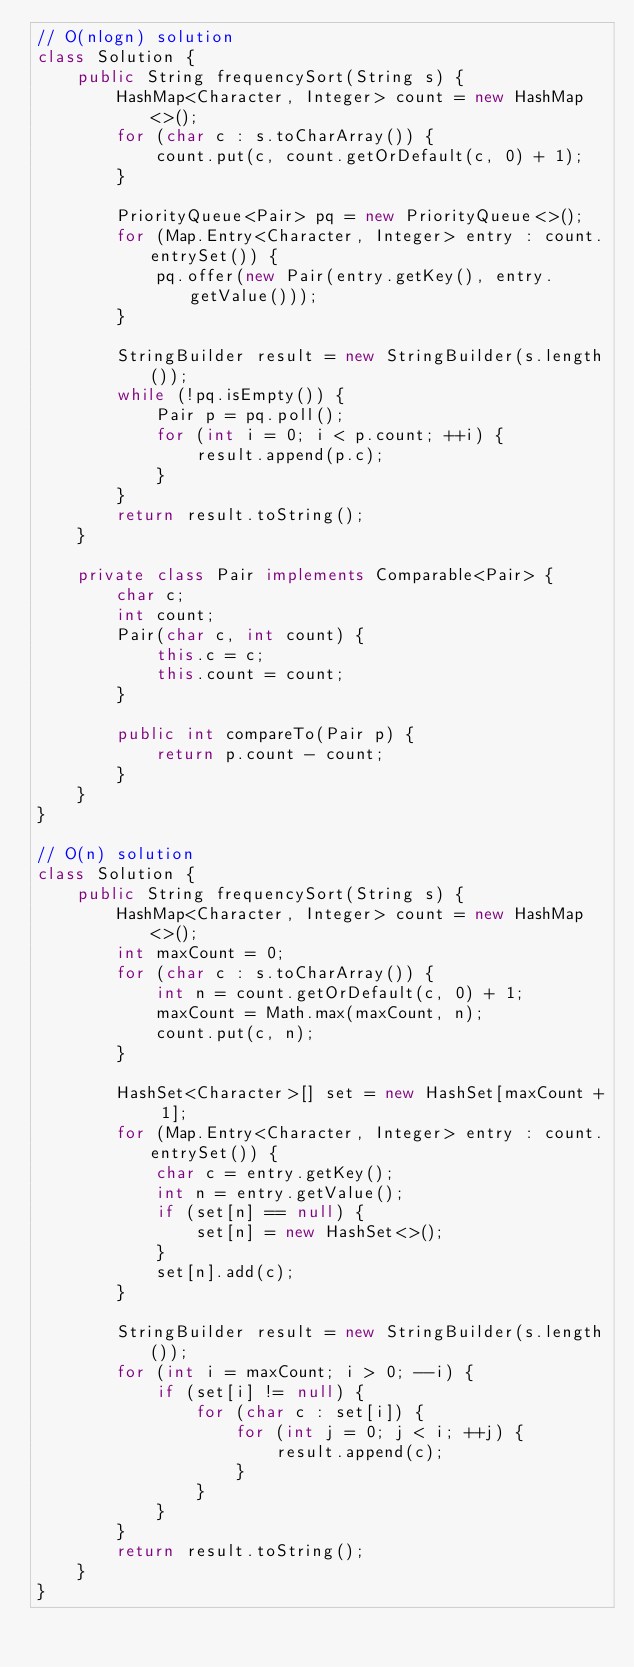<code> <loc_0><loc_0><loc_500><loc_500><_Java_>// O(nlogn) solution
class Solution {
    public String frequencySort(String s) {
        HashMap<Character, Integer> count = new HashMap<>();
        for (char c : s.toCharArray()) {
            count.put(c, count.getOrDefault(c, 0) + 1);
        }
        
        PriorityQueue<Pair> pq = new PriorityQueue<>();
        for (Map.Entry<Character, Integer> entry : count.entrySet()) {
            pq.offer(new Pair(entry.getKey(), entry.getValue()));
        }
        
        StringBuilder result = new StringBuilder(s.length());
        while (!pq.isEmpty()) {
            Pair p = pq.poll();
            for (int i = 0; i < p.count; ++i) {
                result.append(p.c);
            }
        }
        return result.toString();
    }
    
    private class Pair implements Comparable<Pair> {
        char c;
        int count;
        Pair(char c, int count) {
            this.c = c;
            this.count = count;
        }
        
        public int compareTo(Pair p) {
            return p.count - count;
        }
    }
}

// O(n) solution
class Solution {
    public String frequencySort(String s) {
        HashMap<Character, Integer> count = new HashMap<>();
        int maxCount = 0;
        for (char c : s.toCharArray()) {
            int n = count.getOrDefault(c, 0) + 1;
            maxCount = Math.max(maxCount, n);
            count.put(c, n);
        }
        
        HashSet<Character>[] set = new HashSet[maxCount + 1];
        for (Map.Entry<Character, Integer> entry : count.entrySet()) {
            char c = entry.getKey();
            int n = entry.getValue();
            if (set[n] == null) {
                set[n] = new HashSet<>();
            }
            set[n].add(c);
        }
        
        StringBuilder result = new StringBuilder(s.length());
        for (int i = maxCount; i > 0; --i) {
            if (set[i] != null) {
                for (char c : set[i]) {
                    for (int j = 0; j < i; ++j) {
                        result.append(c);
                    }
                }
            }
        }
        return result.toString();
    }
}
</code> 